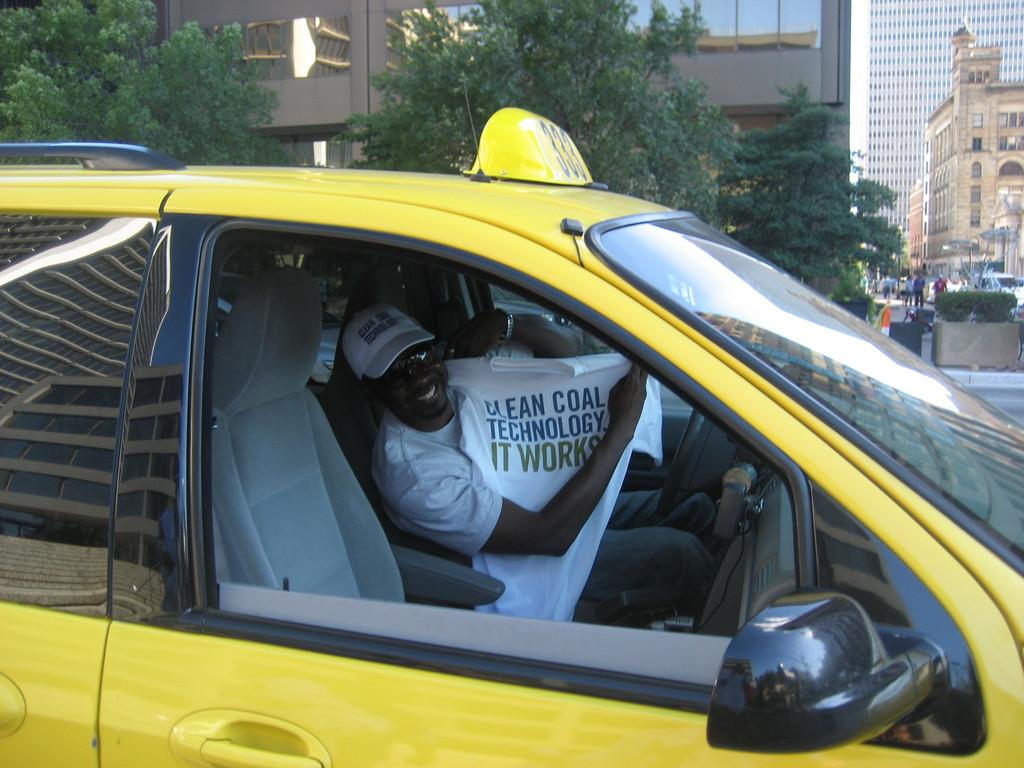Is that a uber driver or an activist?
Provide a short and direct response. Unanswerable. What does the shirt say?
Make the answer very short. Clean coal technology it works. 